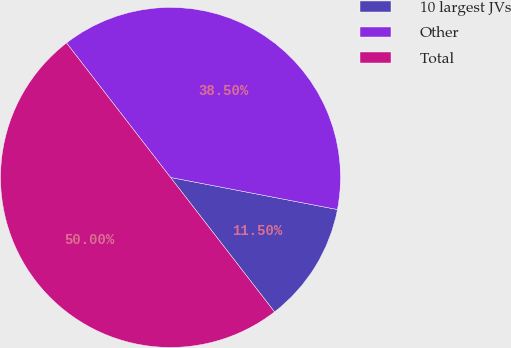Convert chart. <chart><loc_0><loc_0><loc_500><loc_500><pie_chart><fcel>10 largest JVs<fcel>Other<fcel>Total<nl><fcel>11.5%<fcel>38.5%<fcel>50.0%<nl></chart> 